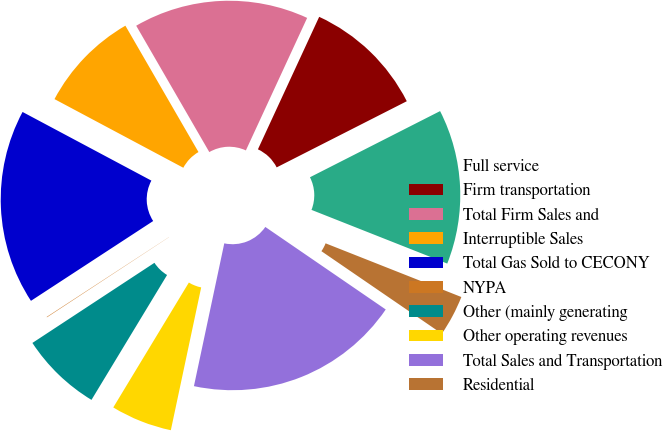Convert chart. <chart><loc_0><loc_0><loc_500><loc_500><pie_chart><fcel>Full service<fcel>Firm transportation<fcel>Total Firm Sales and<fcel>Interruptible Sales<fcel>Total Gas Sold to CECONY<fcel>NYPA<fcel>Other (mainly generating<fcel>Other operating revenues<fcel>Total Sales and Transportation<fcel>Residential<nl><fcel>13.48%<fcel>10.62%<fcel>15.24%<fcel>8.86%<fcel>17.0%<fcel>0.04%<fcel>7.09%<fcel>5.33%<fcel>18.77%<fcel>3.57%<nl></chart> 